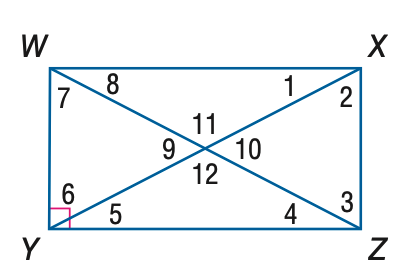Answer the mathemtical geometry problem and directly provide the correct option letter.
Question: Quadrilateral W X Y Z is a rectangle. Find the measure of \angle 12 if m \angle 1 = 30.
Choices: A: 60 B: 90 C: 120 D: 150 C 